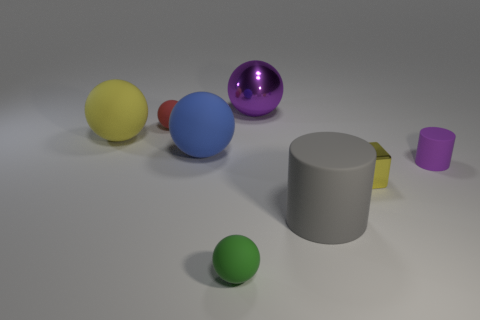There is a tiny ball behind the blue object; how many metal spheres are on the left side of it?
Your response must be concise. 0. What is the color of the other big rubber object that is the same shape as the big yellow rubber object?
Your answer should be very brief. Blue. Is the big purple sphere made of the same material as the small red thing?
Provide a short and direct response. No. How many cylinders are either metallic objects or rubber objects?
Your answer should be very brief. 2. What size is the matte ball that is in front of the purple object in front of the small rubber object that is left of the small green object?
Provide a short and direct response. Small. The purple object that is the same shape as the blue rubber object is what size?
Your answer should be compact. Large. What number of big gray rubber cylinders are behind the metallic cube?
Offer a terse response. 0. Do the tiny matte object on the left side of the big blue sphere and the big shiny ball have the same color?
Your response must be concise. No. What number of red things are tiny rubber things or large balls?
Ensure brevity in your answer.  1. There is a large sphere that is to the left of the small sphere that is behind the yellow ball; what color is it?
Make the answer very short. Yellow. 